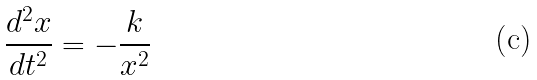Convert formula to latex. <formula><loc_0><loc_0><loc_500><loc_500>\frac { d ^ { 2 } x } { d t ^ { 2 } } = - \frac { k } { x ^ { 2 } }</formula> 